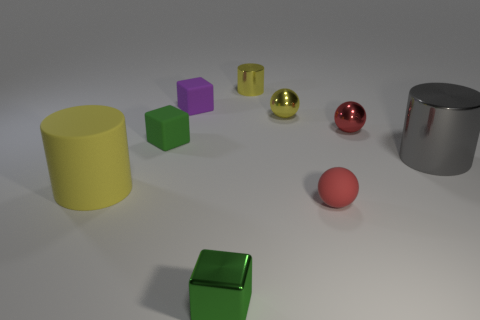Subtract all balls. How many objects are left? 6 Add 1 gray metallic cylinders. How many gray metallic cylinders exist? 2 Subtract 1 yellow spheres. How many objects are left? 8 Subtract all yellow cylinders. Subtract all big metallic cylinders. How many objects are left? 6 Add 3 yellow metallic cylinders. How many yellow metallic cylinders are left? 4 